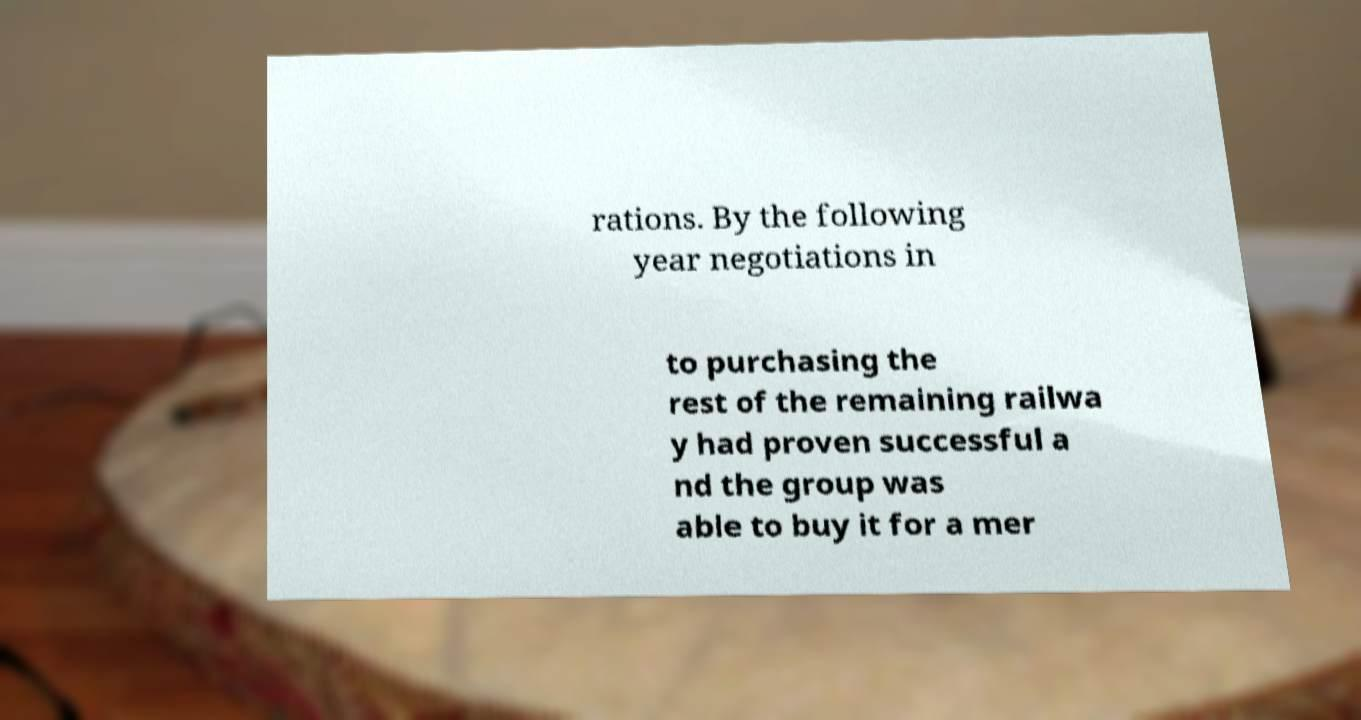What messages or text are displayed in this image? I need them in a readable, typed format. rations. By the following year negotiations in to purchasing the rest of the remaining railwa y had proven successful a nd the group was able to buy it for a mer 